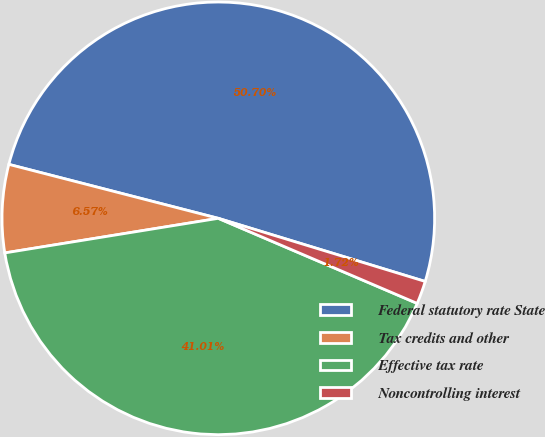<chart> <loc_0><loc_0><loc_500><loc_500><pie_chart><fcel>Federal statutory rate State<fcel>Tax credits and other<fcel>Effective tax rate<fcel>Noncontrolling interest<nl><fcel>50.7%<fcel>6.57%<fcel>41.01%<fcel>1.72%<nl></chart> 